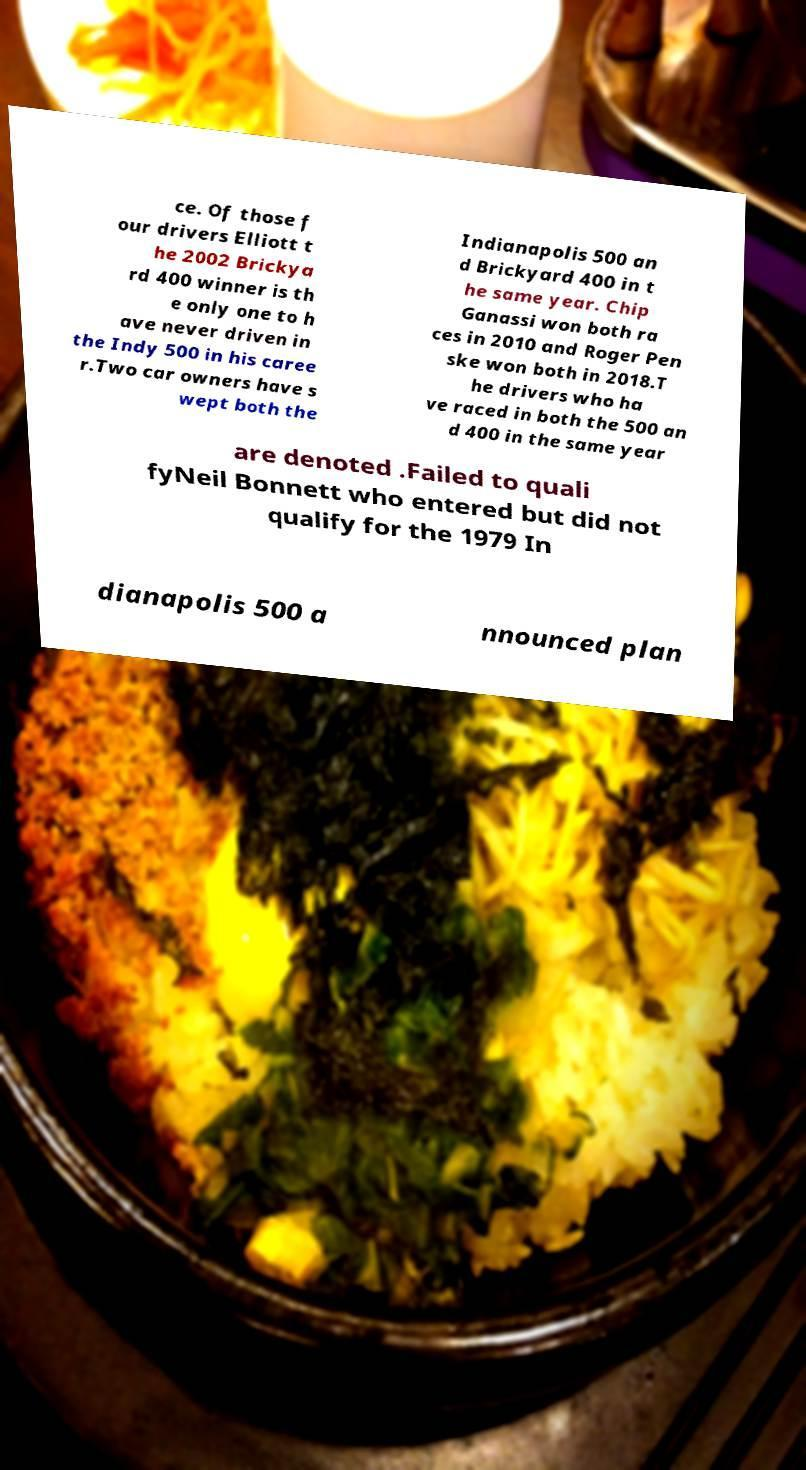Can you read and provide the text displayed in the image?This photo seems to have some interesting text. Can you extract and type it out for me? ce. Of those f our drivers Elliott t he 2002 Brickya rd 400 winner is th e only one to h ave never driven in the Indy 500 in his caree r.Two car owners have s wept both the Indianapolis 500 an d Brickyard 400 in t he same year. Chip Ganassi won both ra ces in 2010 and Roger Pen ske won both in 2018.T he drivers who ha ve raced in both the 500 an d 400 in the same year are denoted .Failed to quali fyNeil Bonnett who entered but did not qualify for the 1979 In dianapolis 500 a nnounced plan 